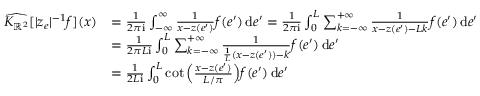Convert formula to latex. <formula><loc_0><loc_0><loc_500><loc_500>\begin{array} { r l } { \widehat { K _ { \mathbb { R } ^ { 2 } } } [ | z _ { e } | ^ { - 1 } f ] ( x ) } & { = \frac { 1 } 2 \pi i } \int _ { - \infty } ^ { \infty } \frac { 1 } { x - z ( e ^ { \prime } ) } f ( e ^ { \prime } ) \, d e ^ { \prime } = \frac { 1 } 2 \pi i } \int _ { 0 } ^ { L } \sum _ { k = - \infty } ^ { + \infty } \frac { 1 } { x - z ( e ^ { \prime } ) - L k } f ( e ^ { \prime } ) \, d e ^ { \prime } } \\ & { = \frac { 1 } { 2 \pi L i } \int _ { 0 } ^ { L } \sum _ { k = - \infty } ^ { + \infty } \frac { 1 } { \frac { 1 } { L } ( x - z ( e ^ { \prime } ) ) - k } f ( e ^ { \prime } ) \, d e ^ { \prime } } \\ & { = \frac { 1 } 2 L i } \int _ { 0 } ^ { L } \cot \left ( \frac { x - z ( e ^ { \prime } ) } { L / \pi } \right ) f ( e ^ { \prime } ) \, d e ^ { \prime } } \end{array}</formula> 